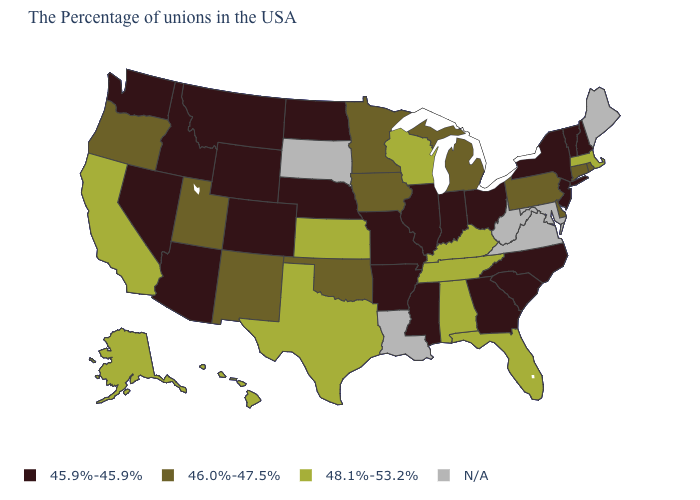What is the value of Kansas?
Short answer required. 48.1%-53.2%. Does Alabama have the highest value in the USA?
Be succinct. Yes. What is the value of West Virginia?
Give a very brief answer. N/A. Is the legend a continuous bar?
Write a very short answer. No. What is the value of Tennessee?
Give a very brief answer. 48.1%-53.2%. Is the legend a continuous bar?
Give a very brief answer. No. Does Wisconsin have the lowest value in the MidWest?
Give a very brief answer. No. Name the states that have a value in the range 45.9%-45.9%?
Concise answer only. New Hampshire, Vermont, New York, New Jersey, North Carolina, South Carolina, Ohio, Georgia, Indiana, Illinois, Mississippi, Missouri, Arkansas, Nebraska, North Dakota, Wyoming, Colorado, Montana, Arizona, Idaho, Nevada, Washington. Among the states that border New Hampshire , does Vermont have the lowest value?
Short answer required. Yes. Does Tennessee have the highest value in the USA?
Keep it brief. Yes. Is the legend a continuous bar?
Short answer required. No. Name the states that have a value in the range N/A?
Be succinct. Maine, Maryland, Virginia, West Virginia, Louisiana, South Dakota. 